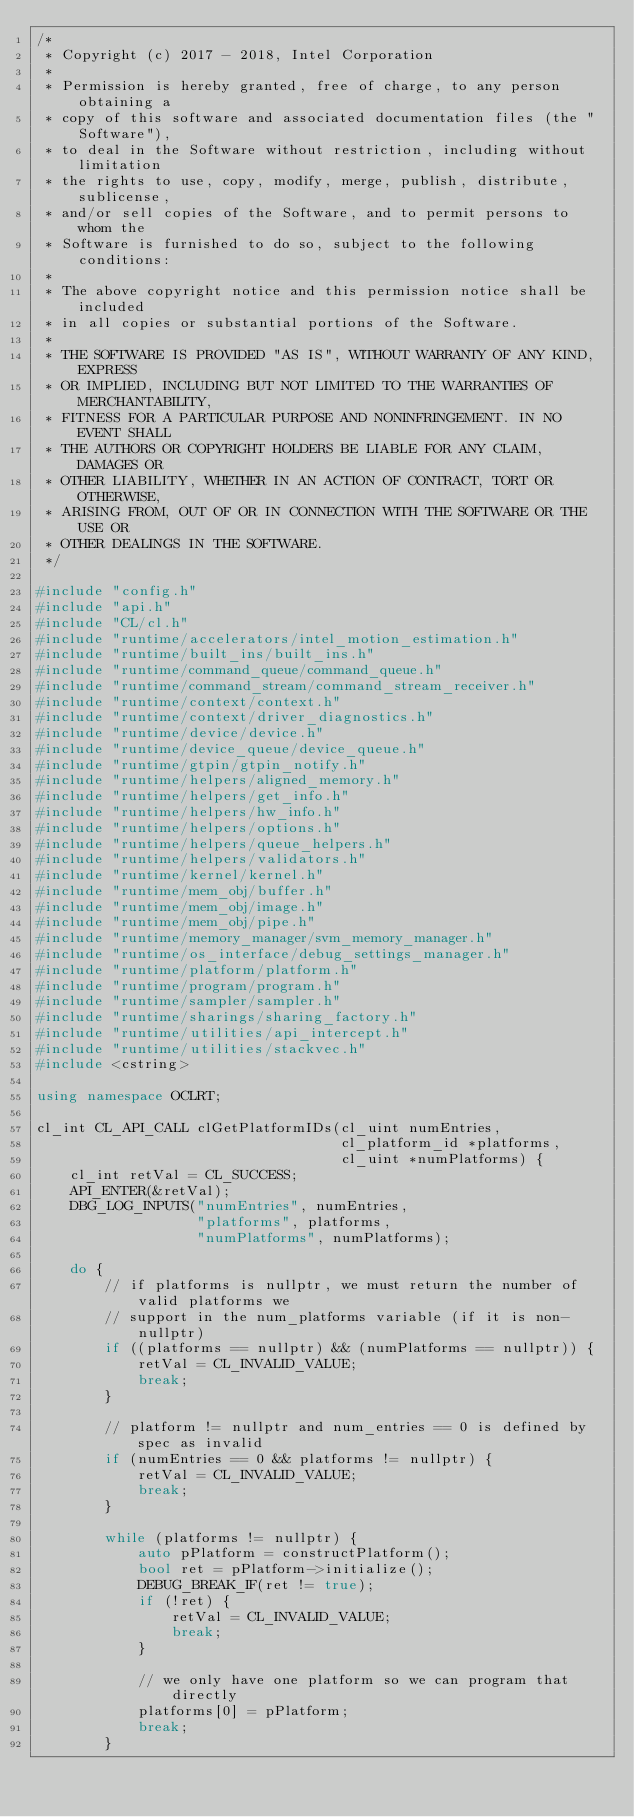Convert code to text. <code><loc_0><loc_0><loc_500><loc_500><_C++_>/*
 * Copyright (c) 2017 - 2018, Intel Corporation
 *
 * Permission is hereby granted, free of charge, to any person obtaining a
 * copy of this software and associated documentation files (the "Software"),
 * to deal in the Software without restriction, including without limitation
 * the rights to use, copy, modify, merge, publish, distribute, sublicense,
 * and/or sell copies of the Software, and to permit persons to whom the
 * Software is furnished to do so, subject to the following conditions:
 *
 * The above copyright notice and this permission notice shall be included
 * in all copies or substantial portions of the Software.
 *
 * THE SOFTWARE IS PROVIDED "AS IS", WITHOUT WARRANTY OF ANY KIND, EXPRESS
 * OR IMPLIED, INCLUDING BUT NOT LIMITED TO THE WARRANTIES OF MERCHANTABILITY,
 * FITNESS FOR A PARTICULAR PURPOSE AND NONINFRINGEMENT. IN NO EVENT SHALL
 * THE AUTHORS OR COPYRIGHT HOLDERS BE LIABLE FOR ANY CLAIM, DAMAGES OR
 * OTHER LIABILITY, WHETHER IN AN ACTION OF CONTRACT, TORT OR OTHERWISE,
 * ARISING FROM, OUT OF OR IN CONNECTION WITH THE SOFTWARE OR THE USE OR
 * OTHER DEALINGS IN THE SOFTWARE.
 */

#include "config.h"
#include "api.h"
#include "CL/cl.h"
#include "runtime/accelerators/intel_motion_estimation.h"
#include "runtime/built_ins/built_ins.h"
#include "runtime/command_queue/command_queue.h"
#include "runtime/command_stream/command_stream_receiver.h"
#include "runtime/context/context.h"
#include "runtime/context/driver_diagnostics.h"
#include "runtime/device/device.h"
#include "runtime/device_queue/device_queue.h"
#include "runtime/gtpin/gtpin_notify.h"
#include "runtime/helpers/aligned_memory.h"
#include "runtime/helpers/get_info.h"
#include "runtime/helpers/hw_info.h"
#include "runtime/helpers/options.h"
#include "runtime/helpers/queue_helpers.h"
#include "runtime/helpers/validators.h"
#include "runtime/kernel/kernel.h"
#include "runtime/mem_obj/buffer.h"
#include "runtime/mem_obj/image.h"
#include "runtime/mem_obj/pipe.h"
#include "runtime/memory_manager/svm_memory_manager.h"
#include "runtime/os_interface/debug_settings_manager.h"
#include "runtime/platform/platform.h"
#include "runtime/program/program.h"
#include "runtime/sampler/sampler.h"
#include "runtime/sharings/sharing_factory.h"
#include "runtime/utilities/api_intercept.h"
#include "runtime/utilities/stackvec.h"
#include <cstring>

using namespace OCLRT;

cl_int CL_API_CALL clGetPlatformIDs(cl_uint numEntries,
                                    cl_platform_id *platforms,
                                    cl_uint *numPlatforms) {
    cl_int retVal = CL_SUCCESS;
    API_ENTER(&retVal);
    DBG_LOG_INPUTS("numEntries", numEntries,
                   "platforms", platforms,
                   "numPlatforms", numPlatforms);

    do {
        // if platforms is nullptr, we must return the number of valid platforms we
        // support in the num_platforms variable (if it is non-nullptr)
        if ((platforms == nullptr) && (numPlatforms == nullptr)) {
            retVal = CL_INVALID_VALUE;
            break;
        }

        // platform != nullptr and num_entries == 0 is defined by spec as invalid
        if (numEntries == 0 && platforms != nullptr) {
            retVal = CL_INVALID_VALUE;
            break;
        }

        while (platforms != nullptr) {
            auto pPlatform = constructPlatform();
            bool ret = pPlatform->initialize();
            DEBUG_BREAK_IF(ret != true);
            if (!ret) {
                retVal = CL_INVALID_VALUE;
                break;
            }

            // we only have one platform so we can program that directly
            platforms[0] = pPlatform;
            break;
        }
</code> 